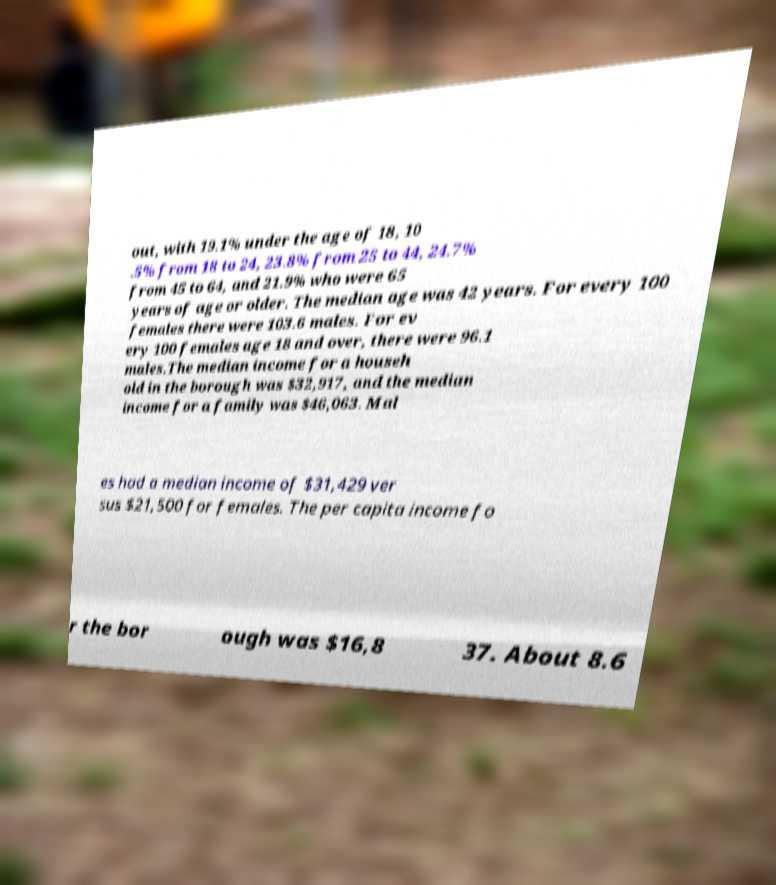Could you assist in decoding the text presented in this image and type it out clearly? out, with 19.1% under the age of 18, 10 .5% from 18 to 24, 23.8% from 25 to 44, 24.7% from 45 to 64, and 21.9% who were 65 years of age or older. The median age was 42 years. For every 100 females there were 103.6 males. For ev ery 100 females age 18 and over, there were 96.1 males.The median income for a househ old in the borough was $32,917, and the median income for a family was $46,063. Mal es had a median income of $31,429 ver sus $21,500 for females. The per capita income fo r the bor ough was $16,8 37. About 8.6 